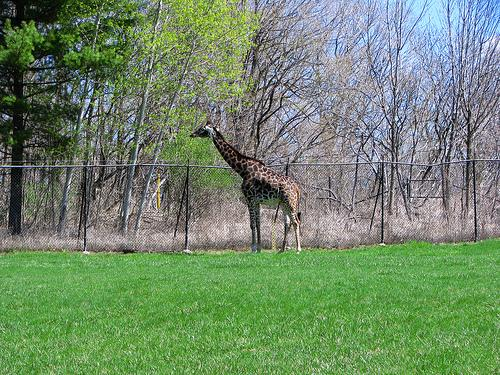Write a brief summary of the central figure in the image and the environment. A tall giraffe with brown spots grazes on leaves near a chain link fence, surrounded by green grass and trees. Provide a concise explanation of the primary animal's actions in the image. The giraffe stands near a fence, consuming foliage from trees in a grassy area. Mention the most prominent animal in the picture and its aspects. An orange and brown giraffe with four legs and a long neck is present, eating from trees in a grassy area. Explain the main subject in the picture and their activity in simple terms. A giraffe is eating leaves from trees near a fence, surrounded by grass and trees. In a single sentence, describe the scene in the image while focusing on the main subject. The image captures a tall giraffe with brown and white markings, grazing near a fence line surrounded by trees. Identify the most noticeable animal in the photo and its location. A giraffe with brown spots stands by a chain-link fence, eating leaves in the proximity of the enclosure. Provide a short description of the primary object in the image and its activity. A giraffe with brown spots is standing beside a chain link fence, eating leaves from nearby trees. Explain the position and action of the main creature in the image. A giraffe is standing by a fence line while munching on leaves from trees close to it. What is the primary animal doing in the picture, and what surrounds it? The giraffe is eating from trees, surrounded by green grass, a fence, and trees with and without leaves. Describe the principal subject of the image and its surroundings. The image shows a brown and white giraffe with a long neck standing by a fence, eating leaves from adjacent trees. 